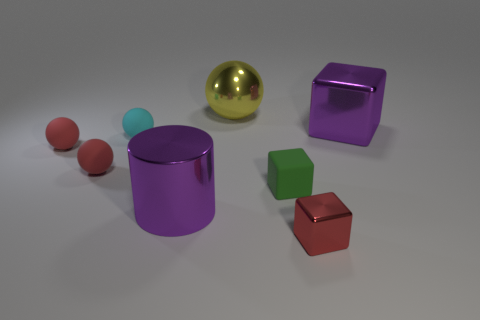What number of things are either big brown cylinders or red shiny cubes?
Your answer should be compact. 1. Does the purple shiny thing that is to the left of the big yellow sphere have the same shape as the small cyan matte object?
Keep it short and to the point. No. What color is the big thing behind the big thing right of the small red metallic thing?
Keep it short and to the point. Yellow. Are there fewer big spheres than metal blocks?
Provide a short and direct response. Yes. Are there any red objects made of the same material as the cylinder?
Your answer should be very brief. Yes. There is a tiny green object; is it the same shape as the purple object to the right of the big shiny cylinder?
Make the answer very short. Yes. There is a big purple cube; are there any cubes to the left of it?
Make the answer very short. Yes. What number of other tiny things are the same shape as the green thing?
Offer a very short reply. 1. Is the green thing made of the same material as the tiny cyan thing left of the red shiny object?
Provide a short and direct response. Yes. What number of cylinders are there?
Keep it short and to the point. 1. 